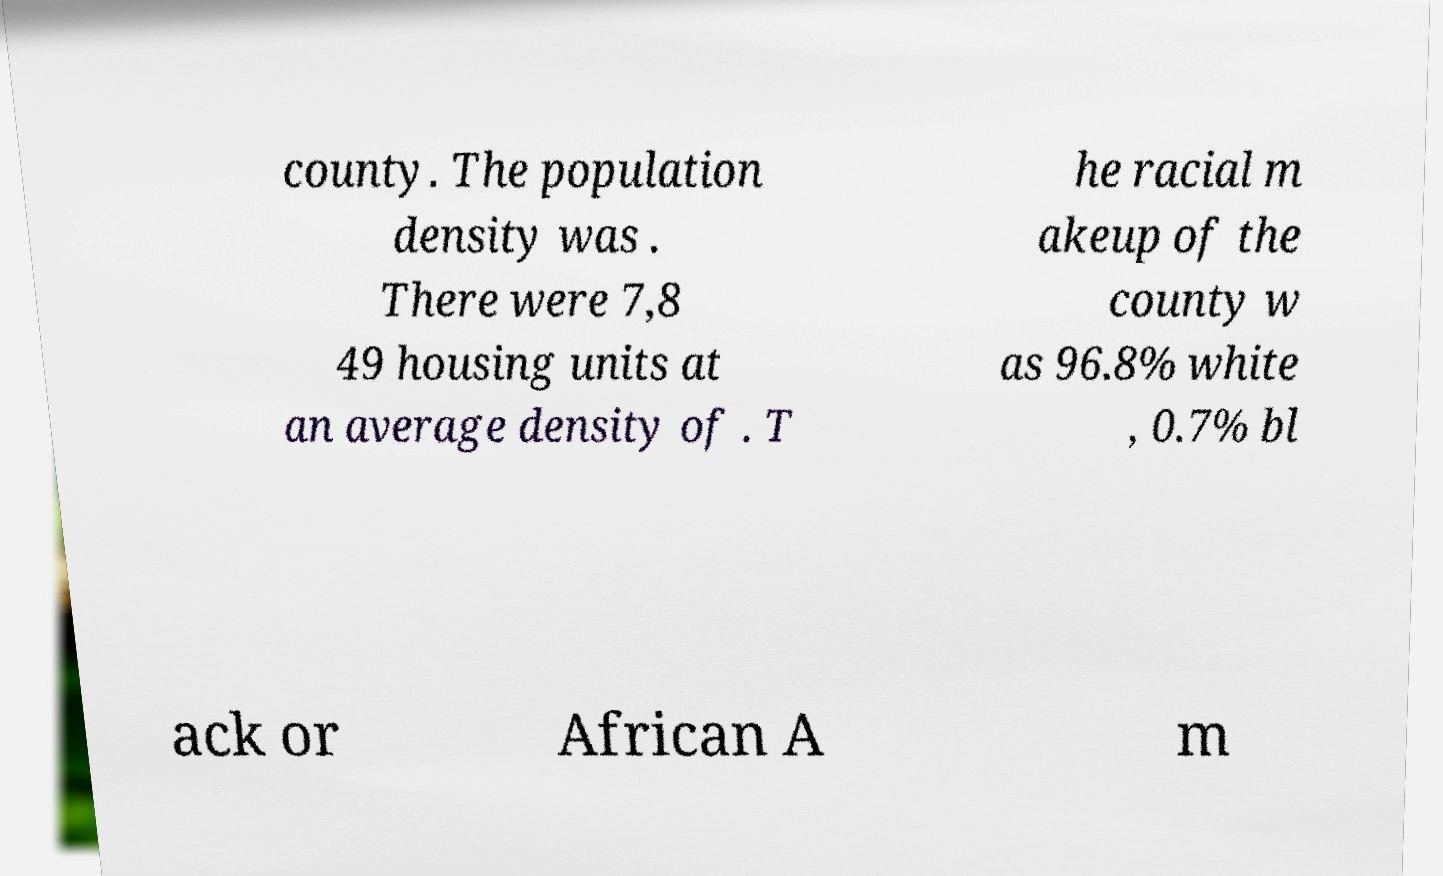Could you assist in decoding the text presented in this image and type it out clearly? county. The population density was . There were 7,8 49 housing units at an average density of . T he racial m akeup of the county w as 96.8% white , 0.7% bl ack or African A m 